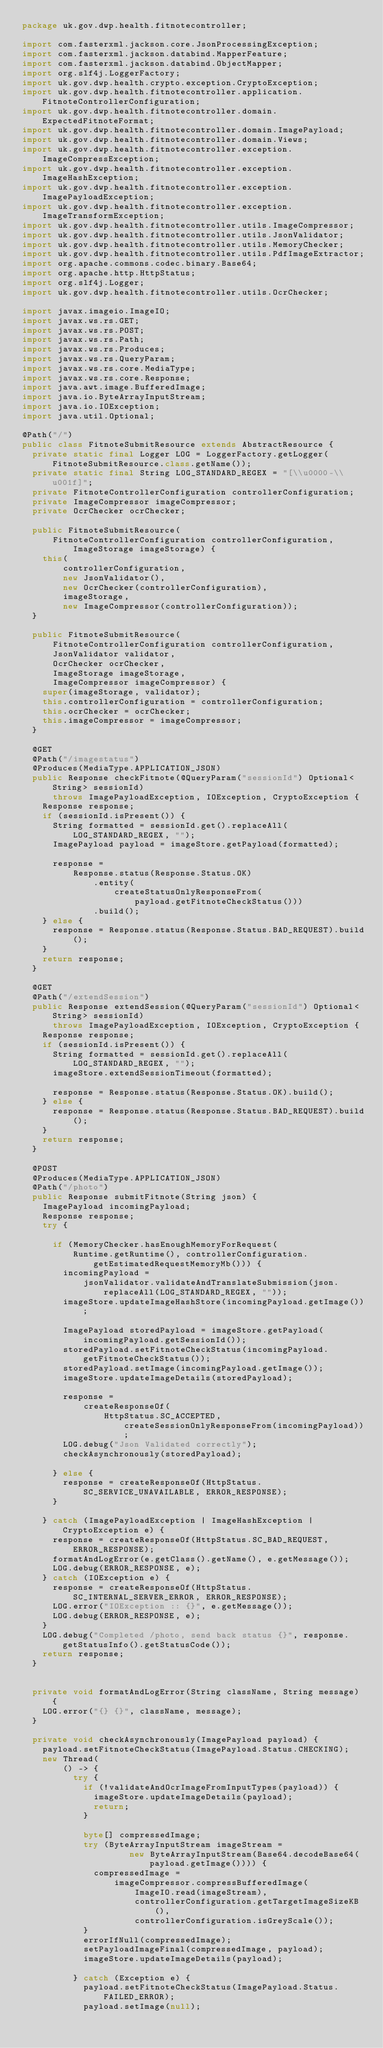Convert code to text. <code><loc_0><loc_0><loc_500><loc_500><_Java_>package uk.gov.dwp.health.fitnotecontroller;

import com.fasterxml.jackson.core.JsonProcessingException;
import com.fasterxml.jackson.databind.MapperFeature;
import com.fasterxml.jackson.databind.ObjectMapper;
import org.slf4j.LoggerFactory;
import uk.gov.dwp.health.crypto.exception.CryptoException;
import uk.gov.dwp.health.fitnotecontroller.application.FitnoteControllerConfiguration;
import uk.gov.dwp.health.fitnotecontroller.domain.ExpectedFitnoteFormat;
import uk.gov.dwp.health.fitnotecontroller.domain.ImagePayload;
import uk.gov.dwp.health.fitnotecontroller.domain.Views;
import uk.gov.dwp.health.fitnotecontroller.exception.ImageCompressException;
import uk.gov.dwp.health.fitnotecontroller.exception.ImageHashException;
import uk.gov.dwp.health.fitnotecontroller.exception.ImagePayloadException;
import uk.gov.dwp.health.fitnotecontroller.exception.ImageTransformException;
import uk.gov.dwp.health.fitnotecontroller.utils.ImageCompressor;
import uk.gov.dwp.health.fitnotecontroller.utils.JsonValidator;
import uk.gov.dwp.health.fitnotecontroller.utils.MemoryChecker;
import uk.gov.dwp.health.fitnotecontroller.utils.PdfImageExtractor;
import org.apache.commons.codec.binary.Base64;
import org.apache.http.HttpStatus;
import org.slf4j.Logger;
import uk.gov.dwp.health.fitnotecontroller.utils.OcrChecker;

import javax.imageio.ImageIO;
import javax.ws.rs.GET;
import javax.ws.rs.POST;
import javax.ws.rs.Path;
import javax.ws.rs.Produces;
import javax.ws.rs.QueryParam;
import javax.ws.rs.core.MediaType;
import javax.ws.rs.core.Response;
import java.awt.image.BufferedImage;
import java.io.ByteArrayInputStream;
import java.io.IOException;
import java.util.Optional;

@Path("/")
public class FitnoteSubmitResource extends AbstractResource {
  private static final Logger LOG = LoggerFactory.getLogger(FitnoteSubmitResource.class.getName());
  private static final String LOG_STANDARD_REGEX = "[\\u0000-\\u001f]";
  private FitnoteControllerConfiguration controllerConfiguration;
  private ImageCompressor imageCompressor;
  private OcrChecker ocrChecker;

  public FitnoteSubmitResource(
      FitnoteControllerConfiguration controllerConfiguration, ImageStorage imageStorage) {
    this(
        controllerConfiguration,
        new JsonValidator(),
        new OcrChecker(controllerConfiguration),
        imageStorage,
        new ImageCompressor(controllerConfiguration));
  }

  public FitnoteSubmitResource(
      FitnoteControllerConfiguration controllerConfiguration,
      JsonValidator validator,
      OcrChecker ocrChecker,
      ImageStorage imageStorage,
      ImageCompressor imageCompressor) {
    super(imageStorage, validator);
    this.controllerConfiguration = controllerConfiguration;
    this.ocrChecker = ocrChecker;
    this.imageCompressor = imageCompressor;
  }

  @GET
  @Path("/imagestatus")
  @Produces(MediaType.APPLICATION_JSON)
  public Response checkFitnote(@QueryParam("sessionId") Optional<String> sessionId)
      throws ImagePayloadException, IOException, CryptoException {
    Response response;
    if (sessionId.isPresent()) {
      String formatted = sessionId.get().replaceAll(LOG_STANDARD_REGEX, "");
      ImagePayload payload = imageStore.getPayload(formatted);

      response =
          Response.status(Response.Status.OK)
              .entity(
                  createStatusOnlyResponseFrom(
                      payload.getFitnoteCheckStatus()))
              .build();
    } else {
      response = Response.status(Response.Status.BAD_REQUEST).build();
    }
    return response;
  }

  @GET
  @Path("/extendSession")
  public Response extendSession(@QueryParam("sessionId") Optional<String> sessionId)
      throws ImagePayloadException, IOException, CryptoException {
    Response response;
    if (sessionId.isPresent()) {
      String formatted = sessionId.get().replaceAll(LOG_STANDARD_REGEX, "");
      imageStore.extendSessionTimeout(formatted);

      response = Response.status(Response.Status.OK).build();
    } else {
      response = Response.status(Response.Status.BAD_REQUEST).build();
    }
    return response;
  }

  @POST
  @Produces(MediaType.APPLICATION_JSON)
  @Path("/photo")
  public Response submitFitnote(String json) {
    ImagePayload incomingPayload;
    Response response;
    try {

      if (MemoryChecker.hasEnoughMemoryForRequest(
          Runtime.getRuntime(), controllerConfiguration.getEstimatedRequestMemoryMb())) {
        incomingPayload =
            jsonValidator.validateAndTranslateSubmission(json.replaceAll(LOG_STANDARD_REGEX, ""));
        imageStore.updateImageHashStore(incomingPayload.getImage());

        ImagePayload storedPayload = imageStore.getPayload(incomingPayload.getSessionId());
        storedPayload.setFitnoteCheckStatus(incomingPayload.getFitnoteCheckStatus());
        storedPayload.setImage(incomingPayload.getImage());
        imageStore.updateImageDetails(storedPayload);

        response =
            createResponseOf(
                HttpStatus.SC_ACCEPTED, createSessionOnlyResponseFrom(incomingPayload));
        LOG.debug("Json Validated correctly");
        checkAsynchronously(storedPayload);

      } else {
        response = createResponseOf(HttpStatus.SC_SERVICE_UNAVAILABLE, ERROR_RESPONSE);
      }

    } catch (ImagePayloadException | ImageHashException | CryptoException e) {
      response = createResponseOf(HttpStatus.SC_BAD_REQUEST, ERROR_RESPONSE);
      formatAndLogError(e.getClass().getName(), e.getMessage());
      LOG.debug(ERROR_RESPONSE, e);
    } catch (IOException e) {
      response = createResponseOf(HttpStatus.SC_INTERNAL_SERVER_ERROR, ERROR_RESPONSE);
      LOG.error("IOException :: {}", e.getMessage());
      LOG.debug(ERROR_RESPONSE, e);
    }
    LOG.debug("Completed /photo, send back status {}", response.getStatusInfo().getStatusCode());
    return response;
  }


  private void formatAndLogError(String className, String message) {
    LOG.error("{} {}", className, message);
  }

  private void checkAsynchronously(ImagePayload payload) {
    payload.setFitnoteCheckStatus(ImagePayload.Status.CHECKING);
    new Thread(
        () -> {
          try {
            if (!validateAndOcrImageFromInputTypes(payload)) {
              imageStore.updateImageDetails(payload);
              return;
            }

            byte[] compressedImage;
            try (ByteArrayInputStream imageStream =
                     new ByteArrayInputStream(Base64.decodeBase64(payload.getImage()))) {
              compressedImage =
                  imageCompressor.compressBufferedImage(
                      ImageIO.read(imageStream),
                      controllerConfiguration.getTargetImageSizeKB(),
                      controllerConfiguration.isGreyScale());
            }
            errorIfNull(compressedImage);
            setPayloadImageFinal(compressedImage, payload);
            imageStore.updateImageDetails(payload);

          } catch (Exception e) {
            payload.setFitnoteCheckStatus(ImagePayload.Status.FAILED_ERROR);
            payload.setImage(null);
</code> 